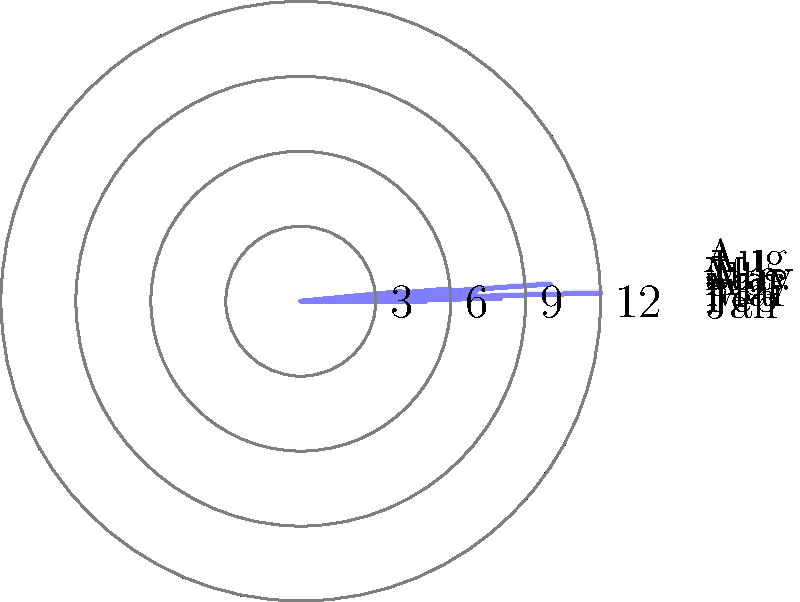The polar histogram shows the number of times celebrity couple "Brangelina" (Brad Pitt and Angelina Jolie) appeared together at public events during the first 8 months of a year. Based on the data, in which month did they make the most public appearances together? To determine the month with the most public appearances, we need to analyze the data presented in the polar histogram:

1. Each sector of the histogram represents a month, starting from January and moving clockwise.
2. The length of each sector corresponds to the number of appearances in that month.
3. We can see that:
   - January (Jan): 5 appearances
   - February (Feb): 8 appearances
   - March (Mar): 12 appearances
   - April (Apr): 3 appearances
   - May (May): 7 appearances
   - June (Jun): 10 appearances
   - July (Jul): 6 appearances
   - August (Aug): 4 appearances

4. The longest sector, indicating the highest number of appearances, corresponds to March with 12 appearances.

Therefore, Brad Pitt and Angelina Jolie made the most public appearances together in March.
Answer: March 